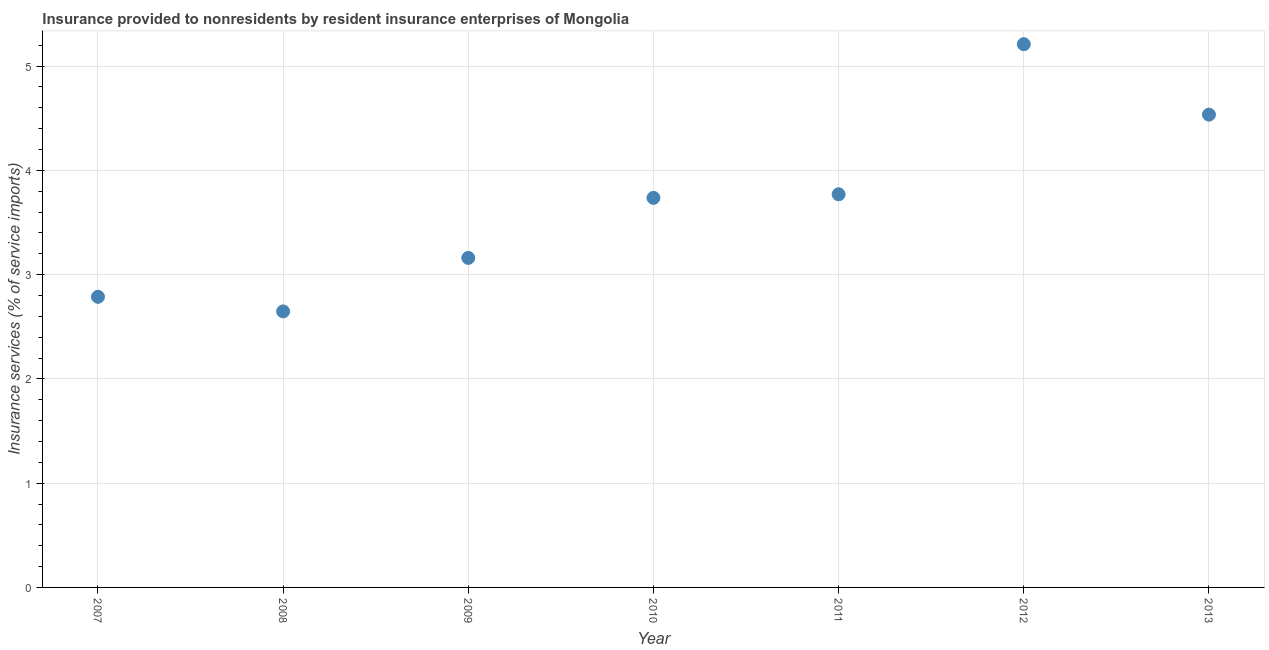What is the insurance and financial services in 2013?
Your answer should be compact. 4.53. Across all years, what is the maximum insurance and financial services?
Offer a terse response. 5.21. Across all years, what is the minimum insurance and financial services?
Your response must be concise. 2.65. What is the sum of the insurance and financial services?
Your answer should be very brief. 25.85. What is the difference between the insurance and financial services in 2010 and 2013?
Provide a short and direct response. -0.8. What is the average insurance and financial services per year?
Your response must be concise. 3.69. What is the median insurance and financial services?
Ensure brevity in your answer.  3.74. In how many years, is the insurance and financial services greater than 4.6 %?
Your answer should be very brief. 1. What is the ratio of the insurance and financial services in 2010 to that in 2012?
Provide a succinct answer. 0.72. What is the difference between the highest and the second highest insurance and financial services?
Your response must be concise. 0.68. Is the sum of the insurance and financial services in 2009 and 2010 greater than the maximum insurance and financial services across all years?
Keep it short and to the point. Yes. What is the difference between the highest and the lowest insurance and financial services?
Your response must be concise. 2.56. Does the insurance and financial services monotonically increase over the years?
Your answer should be compact. No. How many years are there in the graph?
Ensure brevity in your answer.  7. What is the difference between two consecutive major ticks on the Y-axis?
Offer a very short reply. 1. Does the graph contain any zero values?
Offer a very short reply. No. What is the title of the graph?
Your answer should be compact. Insurance provided to nonresidents by resident insurance enterprises of Mongolia. What is the label or title of the Y-axis?
Your response must be concise. Insurance services (% of service imports). What is the Insurance services (% of service imports) in 2007?
Give a very brief answer. 2.79. What is the Insurance services (% of service imports) in 2008?
Provide a short and direct response. 2.65. What is the Insurance services (% of service imports) in 2009?
Ensure brevity in your answer.  3.16. What is the Insurance services (% of service imports) in 2010?
Ensure brevity in your answer.  3.74. What is the Insurance services (% of service imports) in 2011?
Offer a terse response. 3.77. What is the Insurance services (% of service imports) in 2012?
Your answer should be compact. 5.21. What is the Insurance services (% of service imports) in 2013?
Give a very brief answer. 4.53. What is the difference between the Insurance services (% of service imports) in 2007 and 2008?
Give a very brief answer. 0.14. What is the difference between the Insurance services (% of service imports) in 2007 and 2009?
Keep it short and to the point. -0.37. What is the difference between the Insurance services (% of service imports) in 2007 and 2010?
Give a very brief answer. -0.95. What is the difference between the Insurance services (% of service imports) in 2007 and 2011?
Offer a terse response. -0.98. What is the difference between the Insurance services (% of service imports) in 2007 and 2012?
Ensure brevity in your answer.  -2.42. What is the difference between the Insurance services (% of service imports) in 2007 and 2013?
Give a very brief answer. -1.75. What is the difference between the Insurance services (% of service imports) in 2008 and 2009?
Your response must be concise. -0.51. What is the difference between the Insurance services (% of service imports) in 2008 and 2010?
Make the answer very short. -1.09. What is the difference between the Insurance services (% of service imports) in 2008 and 2011?
Your answer should be compact. -1.12. What is the difference between the Insurance services (% of service imports) in 2008 and 2012?
Your response must be concise. -2.56. What is the difference between the Insurance services (% of service imports) in 2008 and 2013?
Offer a terse response. -1.89. What is the difference between the Insurance services (% of service imports) in 2009 and 2010?
Give a very brief answer. -0.58. What is the difference between the Insurance services (% of service imports) in 2009 and 2011?
Give a very brief answer. -0.61. What is the difference between the Insurance services (% of service imports) in 2009 and 2012?
Ensure brevity in your answer.  -2.05. What is the difference between the Insurance services (% of service imports) in 2009 and 2013?
Your answer should be compact. -1.37. What is the difference between the Insurance services (% of service imports) in 2010 and 2011?
Keep it short and to the point. -0.03. What is the difference between the Insurance services (% of service imports) in 2010 and 2012?
Your answer should be very brief. -1.47. What is the difference between the Insurance services (% of service imports) in 2010 and 2013?
Make the answer very short. -0.8. What is the difference between the Insurance services (% of service imports) in 2011 and 2012?
Provide a succinct answer. -1.44. What is the difference between the Insurance services (% of service imports) in 2011 and 2013?
Give a very brief answer. -0.76. What is the difference between the Insurance services (% of service imports) in 2012 and 2013?
Provide a succinct answer. 0.68. What is the ratio of the Insurance services (% of service imports) in 2007 to that in 2008?
Provide a succinct answer. 1.05. What is the ratio of the Insurance services (% of service imports) in 2007 to that in 2009?
Your answer should be compact. 0.88. What is the ratio of the Insurance services (% of service imports) in 2007 to that in 2010?
Ensure brevity in your answer.  0.75. What is the ratio of the Insurance services (% of service imports) in 2007 to that in 2011?
Keep it short and to the point. 0.74. What is the ratio of the Insurance services (% of service imports) in 2007 to that in 2012?
Offer a terse response. 0.54. What is the ratio of the Insurance services (% of service imports) in 2007 to that in 2013?
Ensure brevity in your answer.  0.61. What is the ratio of the Insurance services (% of service imports) in 2008 to that in 2009?
Offer a very short reply. 0.84. What is the ratio of the Insurance services (% of service imports) in 2008 to that in 2010?
Your answer should be compact. 0.71. What is the ratio of the Insurance services (% of service imports) in 2008 to that in 2011?
Offer a very short reply. 0.7. What is the ratio of the Insurance services (% of service imports) in 2008 to that in 2012?
Your answer should be compact. 0.51. What is the ratio of the Insurance services (% of service imports) in 2008 to that in 2013?
Keep it short and to the point. 0.58. What is the ratio of the Insurance services (% of service imports) in 2009 to that in 2010?
Make the answer very short. 0.85. What is the ratio of the Insurance services (% of service imports) in 2009 to that in 2011?
Make the answer very short. 0.84. What is the ratio of the Insurance services (% of service imports) in 2009 to that in 2012?
Provide a succinct answer. 0.61. What is the ratio of the Insurance services (% of service imports) in 2009 to that in 2013?
Your response must be concise. 0.7. What is the ratio of the Insurance services (% of service imports) in 2010 to that in 2011?
Your response must be concise. 0.99. What is the ratio of the Insurance services (% of service imports) in 2010 to that in 2012?
Your answer should be compact. 0.72. What is the ratio of the Insurance services (% of service imports) in 2010 to that in 2013?
Ensure brevity in your answer.  0.82. What is the ratio of the Insurance services (% of service imports) in 2011 to that in 2012?
Offer a very short reply. 0.72. What is the ratio of the Insurance services (% of service imports) in 2011 to that in 2013?
Your response must be concise. 0.83. What is the ratio of the Insurance services (% of service imports) in 2012 to that in 2013?
Ensure brevity in your answer.  1.15. 